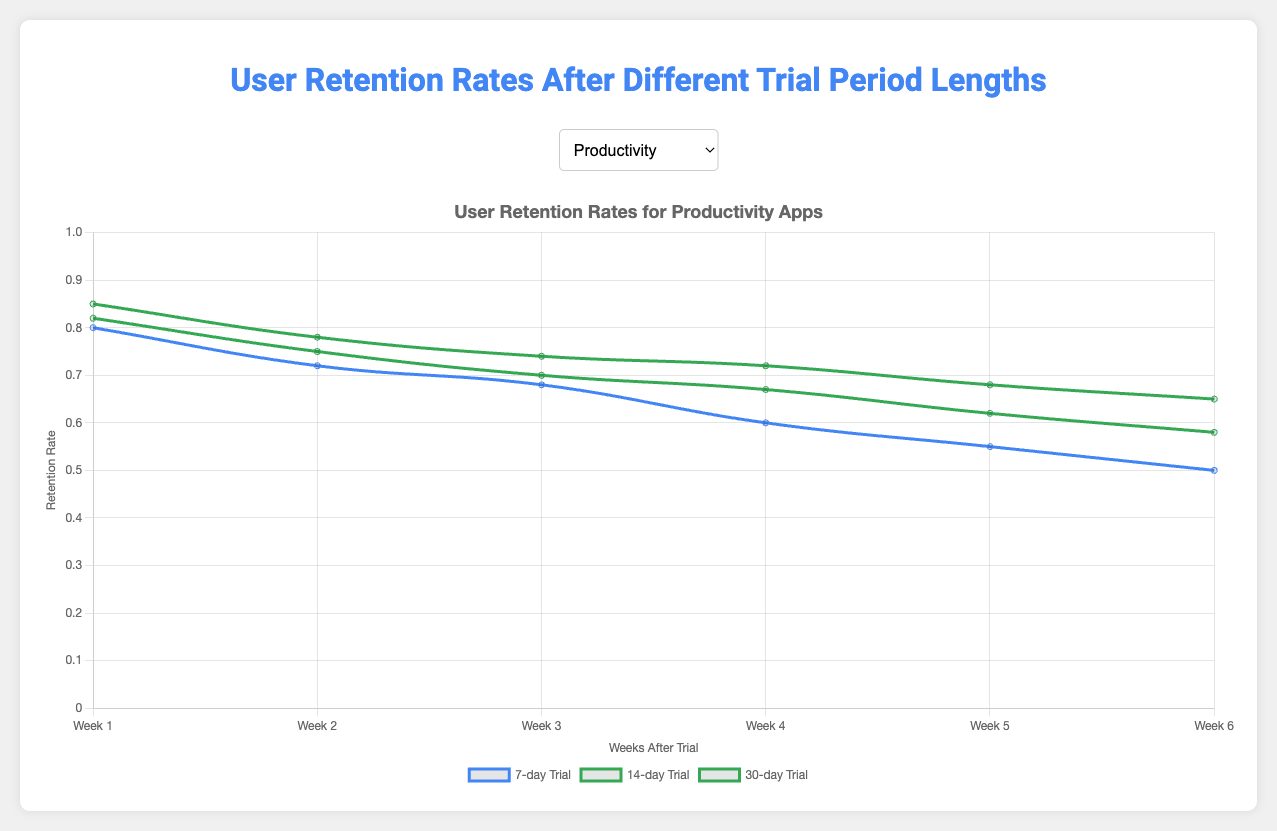What is the highest retention rate for Education apps after the first week? In the figure, select "Education" from the category selector and look at the week 1 retention rates for different trial lengths. The highest value among them is 0.89, which corresponds to the 30-day trial period.
Answer: 0.89 Which trial period length has the lowest retention rate at Week 6 for Gaming apps? Choose "Gaming" from the category selector and analyze the retention rates at Week 6 for all trial periods. The lowest retention rate value among 7-day, 14-day, and 30-day is 0.40, corresponding to the 7-day trial period.
Answer: 7-day What is the difference in retention rates at Week 3 between 14-day and 30-day trial periods for Health & Fitness apps? Select "Health & Fitness" from the category selector, and examine the retention rates for 14-day and 30-day trial periods at Week 3. The values are 0.68 and 0.72, respectively. The difference is calculated as 0.72 - 0.68 = 0.04.
Answer: 0.04 Does the retention rate for Social apps with a 7-day trial period ever surpass that of Productivity apps? Compare retention rates for Social and Productivity at all weeks for the 7-day trial period. The retention rates for Social are consistently lower than those for Productivity.
Answer: No Which app category has the smallest drop in retention rate from Week 1 to Week 2 for any trial period? Inspect the retention rates for all categories from Week 1 to Week 2 for the 7, 14, and 30-day trial periods. The smallest drop is seen for "Education" with a 30-day trial period, where the retention rate drops from 0.89 to 0.83, yielding a drop of 0.06.
Answer: Education What is the average retention rate across all categories at Week 1 for the 7-day trial period? To find the average, add Week 1 retention rates for the 7-day trial period across all categories: (0.80 + 0.70 + 0.76 + 0.85 + 0.60) and divide by the number of categories, 5. The calculation is (0.80 + 0.70 + 0.76 + 0.85 + 0.60) / 5 = 3.71 / 5 = 0.742.
Answer: 0.742 Is it true that the highest retention rate at Week 4 always occurs for the 30-day trial period for each app category? For each category, check the Week 4 retention rates for the 7, 14, and 30-day trial periods. The highest value in each case corresponds to the 30-day trial period.
Answer: Yes What is the sum of retention rates at Week 6 for all categories with a 14-day trial period? Add Week 6 retention rates for the 14-day trial period across all categories: 0.58 (Productivity) + 0.45 (Gaming) + 0.57 (Health & Fitness) + 0.60 (Education) + 0.38 (Social) = 0.58 + 0.45 + 0.57 + 0.60 + 0.38 = 2.58.
Answer: 2.58 Which trial period shows the most significant improvement in retention rates at Week 1 compared to the 7-day trial periods for Productivity apps? Compare the Week 1 retention rates for the 14 and 30-day trial periods to the 7-day trial period for Productivity apps. The increases are 0.82 - 0.80 = 0.02 for 14-day and 0.85 - 0.80 = 0.05 for 30-day. The 30-day trial period shows a more significant improvement.
Answer: 30-day For Health & Fitness apps, which trial length maintains retention rates better from Week 3 to Week 4? View the retention rates for "Health & Fitness" at Weeks 3 and 4. For the 7, 14, and 30-day trial periods, the drops are 0.65 to 0.60 (a drop of 0.05), 0.68 to 0.62 (a drop of 0.06), and 0.72 to 0.67 (a drop of 0.05), respectively. Thus, both 7-day and 30-day trial periods have the smallest drop.
Answer: 7-day and 30-day 